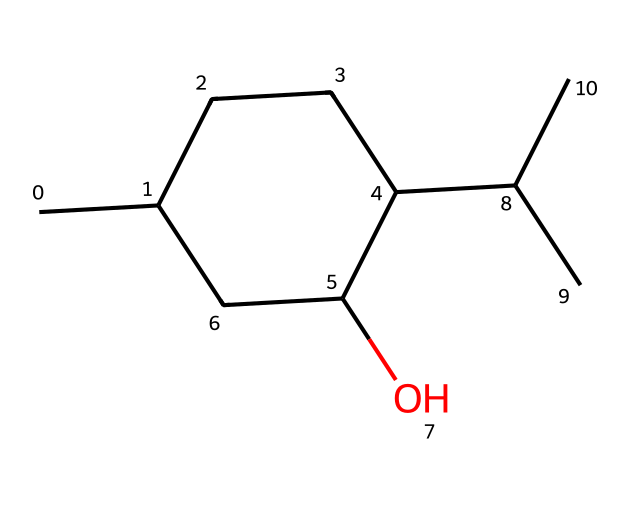What is the molecular formula of menthol? To determine the molecular formula, we need to count the atoms represented in the SMILES structure. By analyzing the structure, we find 10 carbon (C), 20 hydrogen (H), and 1 oxygen (O) atom. Thus, the molecular formula is C10H20O.
Answer: C10H20O How many carbon atoms are present in the structure? By inspecting the SMILES representation, we can identify that there are a total of 10 carbon atoms connected in the structure.
Answer: 10 What type of chemical is menthol classified as? Menthol is a cyclic monoterpene alcohol, which is detailed in its structure showing a hydroxyl (–OH) group bonded to a ring system.
Answer: alcohol What functional group is present in menthol? The presence of a hydroxyl (–OH) group in the chemical structure indicates that menthol contains an alcohol functional group.
Answer: hydroxyl How many hydrogen atoms would remain if all alcohol groups were removed? Since menthol has one hydroxyl (–OH) group, removing this group's hydrogen would leave us with 19 hydrogen atoms (20 initially - 1 from the alcohol).
Answer: 19 Which part of the chemical structure contributes to its characteristic cooling sensation? The presence of the hydroxyl group (–OH) is responsible for the cooling sensation, enhancing menthol's effects on sensory receptors.
Answer: hydroxyl group 